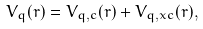<formula> <loc_0><loc_0><loc_500><loc_500>V _ { q } ( r ) = V _ { q , c } ( r ) + V _ { q , x c } ( r ) ,</formula> 